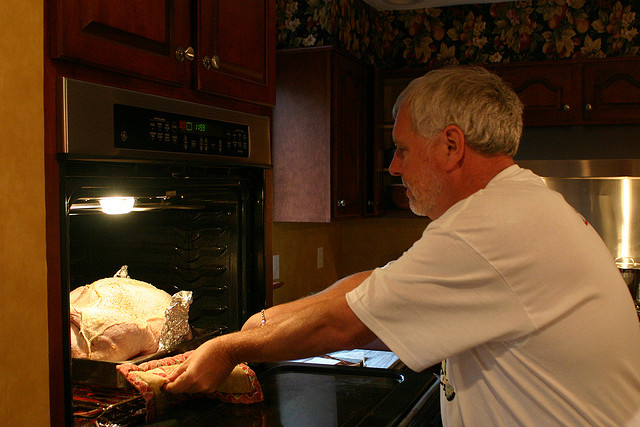<image>What does the top of the oven say? I don't know what the top of the oven says. It can be a time like '11:59' or '1:28', 'firemaker' or even 'temperature'. What does the top of the oven say? I am not sure what the top of the oven says. It can be seen '11:59', 'firemaker', '1 58' or '1:28'. 